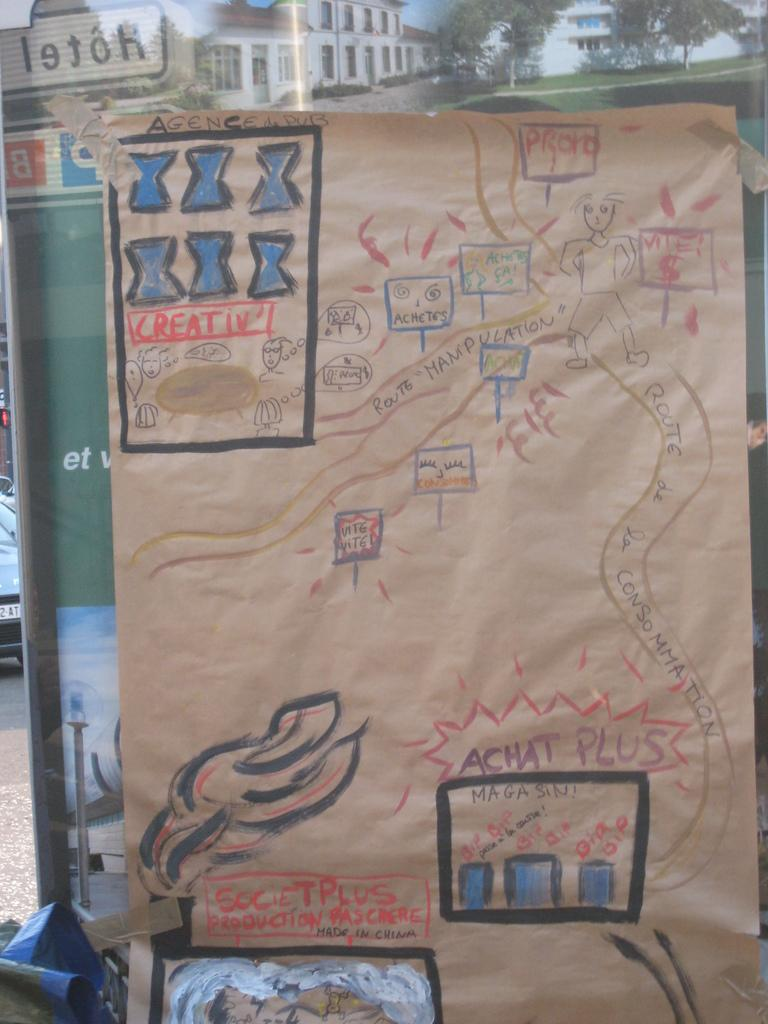<image>
Relay a brief, clear account of the picture shown. a brown piece of paper with the word creative on it 